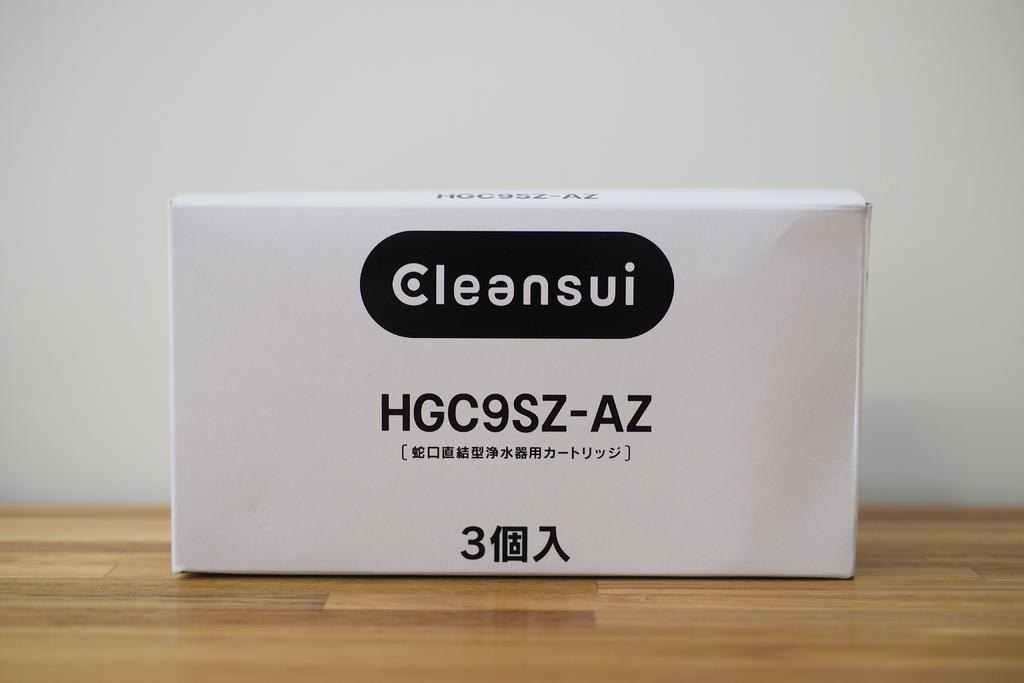<image>
Present a compact description of the photo's key features. white box labeled Cleansui HGC9SZ-AZ on a wood floor 